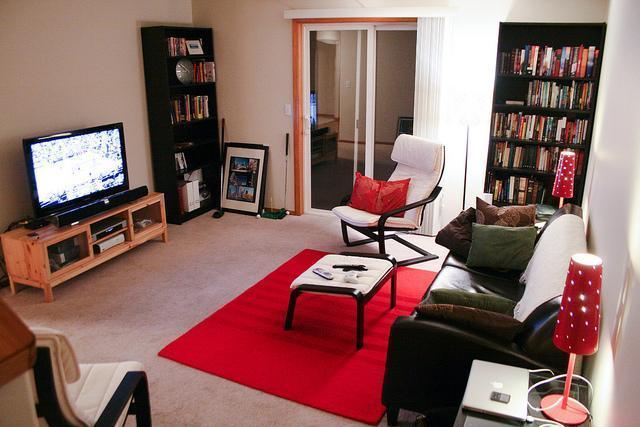How many chairs are in the picture?
Give a very brief answer. 2. 